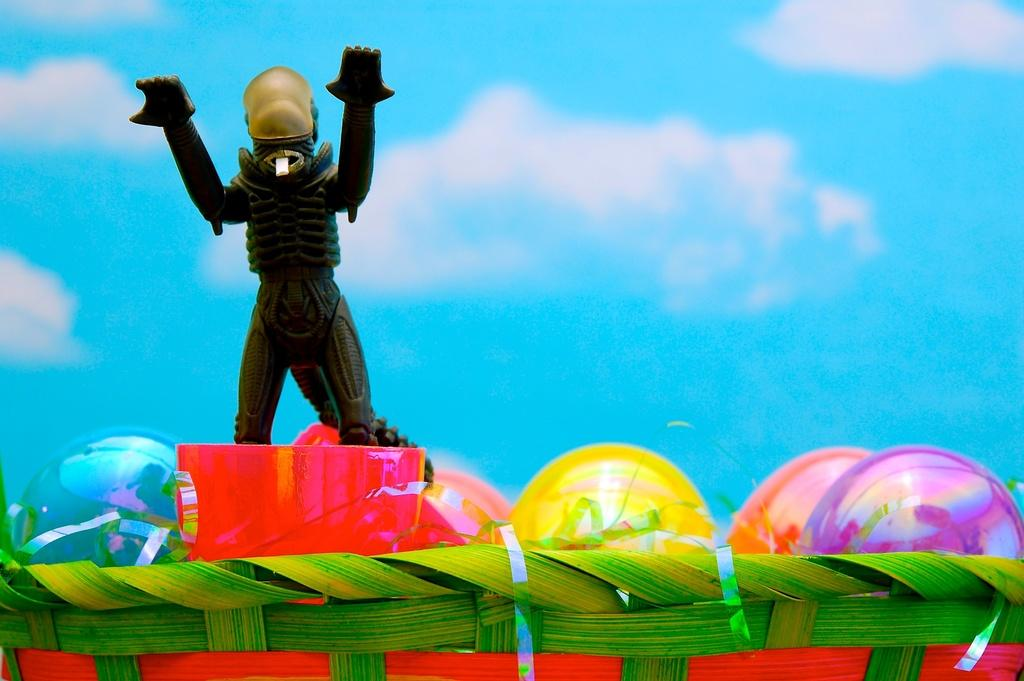What object is present in the image that can hold items? There is a basket in the image that can hold items. What is inside the basket? The basket contains balls and a figurine. What can be seen in the background of the image? The background of the image includes the sky. What is visible in the sky? Clouds are visible in the sky. What type of nail is being used to hold the figurine in place in the image? There is no nail present in the image; the figurine is simply placed inside the basket with the balls. Who is sitting on the throne in the image? There is no throne present in the image; it only features a basket with balls and a figurine. 